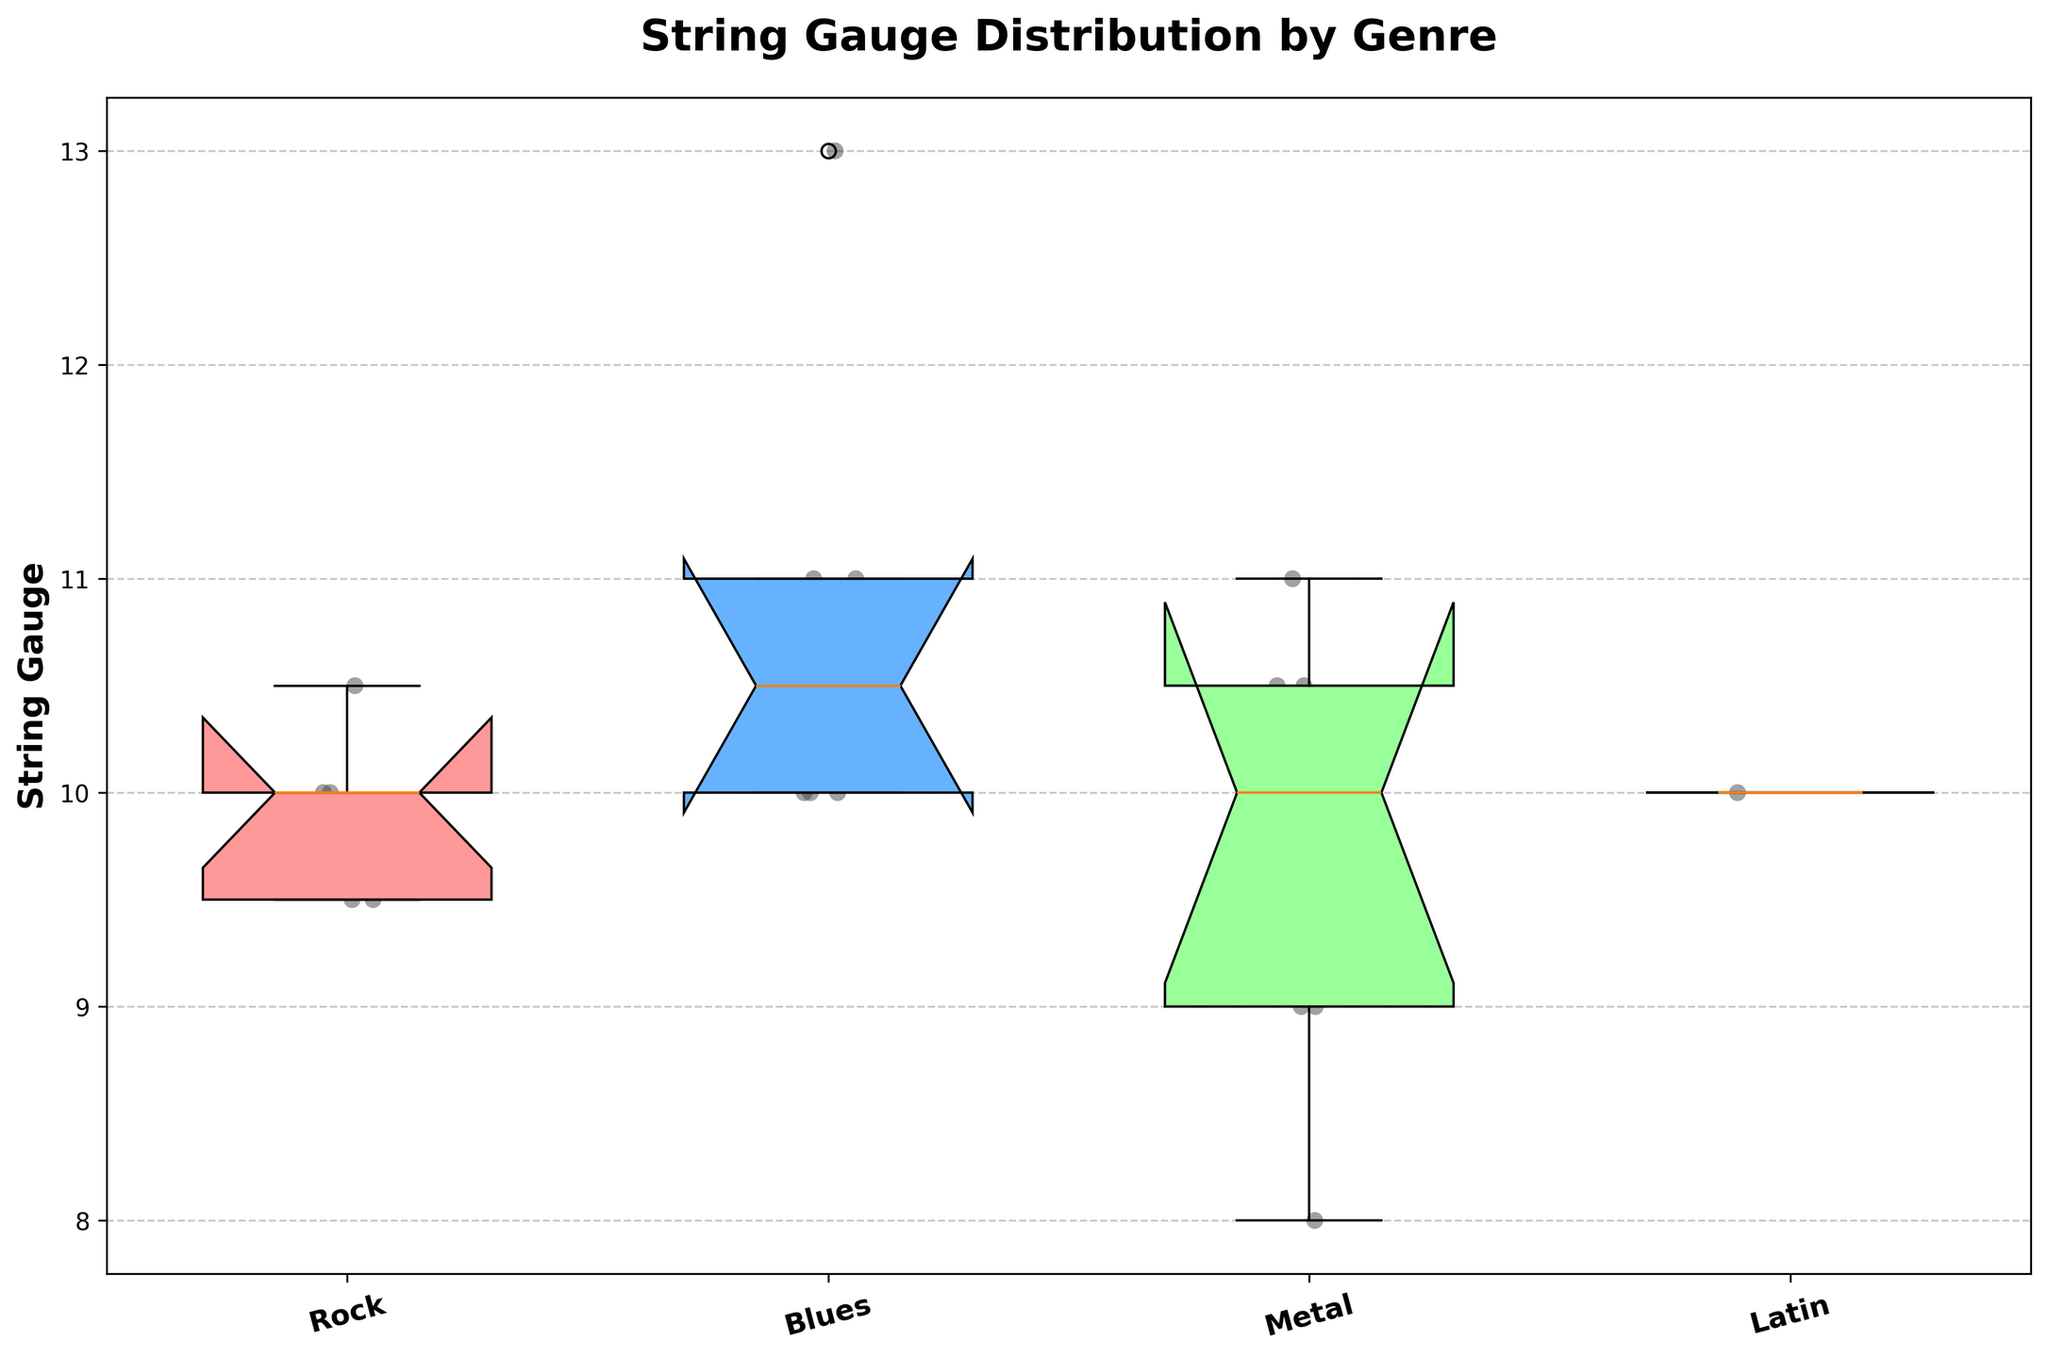What is the title of the plot? The title is usually placed at the top of the plot and describes what the plot is about. In this case, it should be easily visible and clearly states the main subject.
Answer: String Gauge Distribution by Genre What genres are included in the box plot? Genres are typically labeled on the x-axis of the box plot. By checking these labels, you can determine all the relevant genres.
Answer: Rock, Blues, Metal, Latin What does the y-axis represent? The y-axis usually represents the variable being measured or analyzed. In this plot, it should be labeled accordingly.
Answer: String Gauge Which genre has the widest range of string gauge values? The range of string gauge values can be observed by comparing the distance between the minimum and maximum values in each box plot. The genre with the widest spread represents the widest range.
Answer: Blues What is the median string gauge for Metal? The median is indicated by the line inside the box of each distribution. Locate the box plot for the Metal genre and find the value of this line.
Answer: 10 Which genre has the highest median string gauge? Compare the median values (the lines inside the boxes) across all genres to identify the genre with the highest median gauge.
Answer: Metal Between Rock and Latin, which genre shows more variation in string gauge values? Variation can be judged by the length of each box and whiskers. The longer they are, the greater the variation. Compare the box plots for Rock and Latin.
Answer: Rock What is the interquartile range (IQR) for the Rock genre? The IQR is the distance between the first quartile (bottom of the box) and the third quartile (top of the box) in the Rock box plot. Measure this distance on the y-axis.
Answer: 1 Which genre shows the lowest minimum string gauge value? The minimum value is indicated by the bottom whisker of each box plot. Compare these across all genres to find the lowest.
Answer: Metal Are there any outliers in the Blues genre? Outliers in a box plot are typically represented by dots outside the whiskers. Look at the Blues genre's box plot to see if there are any such dots.
Answer: Yes 